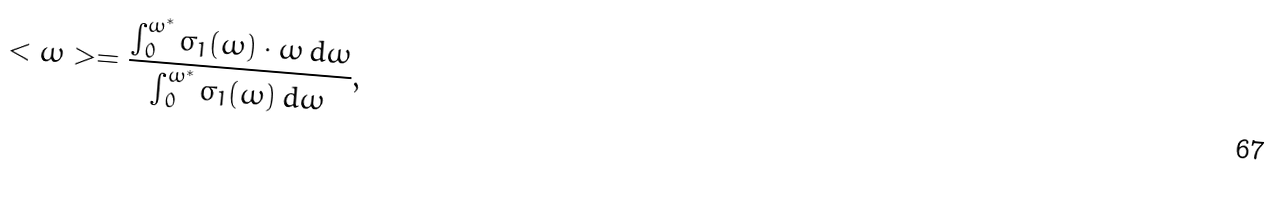Convert formula to latex. <formula><loc_0><loc_0><loc_500><loc_500>< \omega > = \frac { \int _ { 0 } ^ { \omega ^ { * } } \sigma _ { 1 } ( \omega ) \cdot \omega \, d \omega } { \int _ { 0 } ^ { \omega ^ { * } } \sigma _ { 1 } ( \omega ) \, d \omega } ,</formula> 